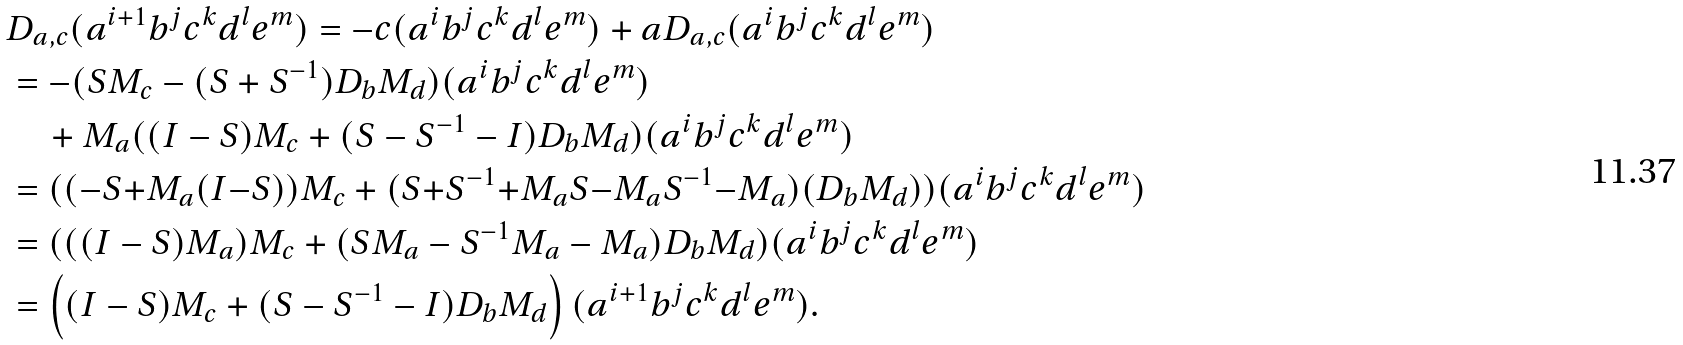<formula> <loc_0><loc_0><loc_500><loc_500>& D _ { a , c } ( a ^ { i + 1 } b ^ { j } c ^ { k } d ^ { l } e ^ { m } ) = - c ( a ^ { i } b ^ { j } c ^ { k } d ^ { l } e ^ { m } ) + a D _ { a , c } ( a ^ { i } b ^ { j } c ^ { k } d ^ { l } e ^ { m } ) \\ & = - ( S M _ { c } - ( S + S ^ { - 1 } ) D _ { b } M _ { d } ) ( a ^ { i } b ^ { j } c ^ { k } d ^ { l } e ^ { m } ) \\ & \quad + M _ { a } ( ( I - S ) M _ { c } + ( S - S ^ { - 1 } - I ) D _ { b } M _ { d } ) ( a ^ { i } b ^ { j } c ^ { k } d ^ { l } e ^ { m } ) \\ & = ( ( - S { + } M _ { a } ( I { - } S ) ) M _ { c } + ( S { + } S ^ { - 1 } { + } M _ { a } S { - } M _ { a } S ^ { - 1 } { - } M _ { a } ) ( D _ { b } M _ { d } ) ) ( a ^ { i } b ^ { j } c ^ { k } d ^ { l } e ^ { m } ) \\ & = ( ( ( I - S ) M _ { a } ) M _ { c } + ( S M _ { a } - S ^ { - 1 } M _ { a } - M _ { a } ) D _ { b } M _ { d } ) ( a ^ { i } b ^ { j } c ^ { k } d ^ { l } e ^ { m } ) \\ & = \left ( ( I - S ) M _ { c } + ( S - S ^ { - 1 } - I ) D _ { b } M _ { d } \right ) ( a ^ { i + 1 } b ^ { j } c ^ { k } d ^ { l } e ^ { m } ) .</formula> 